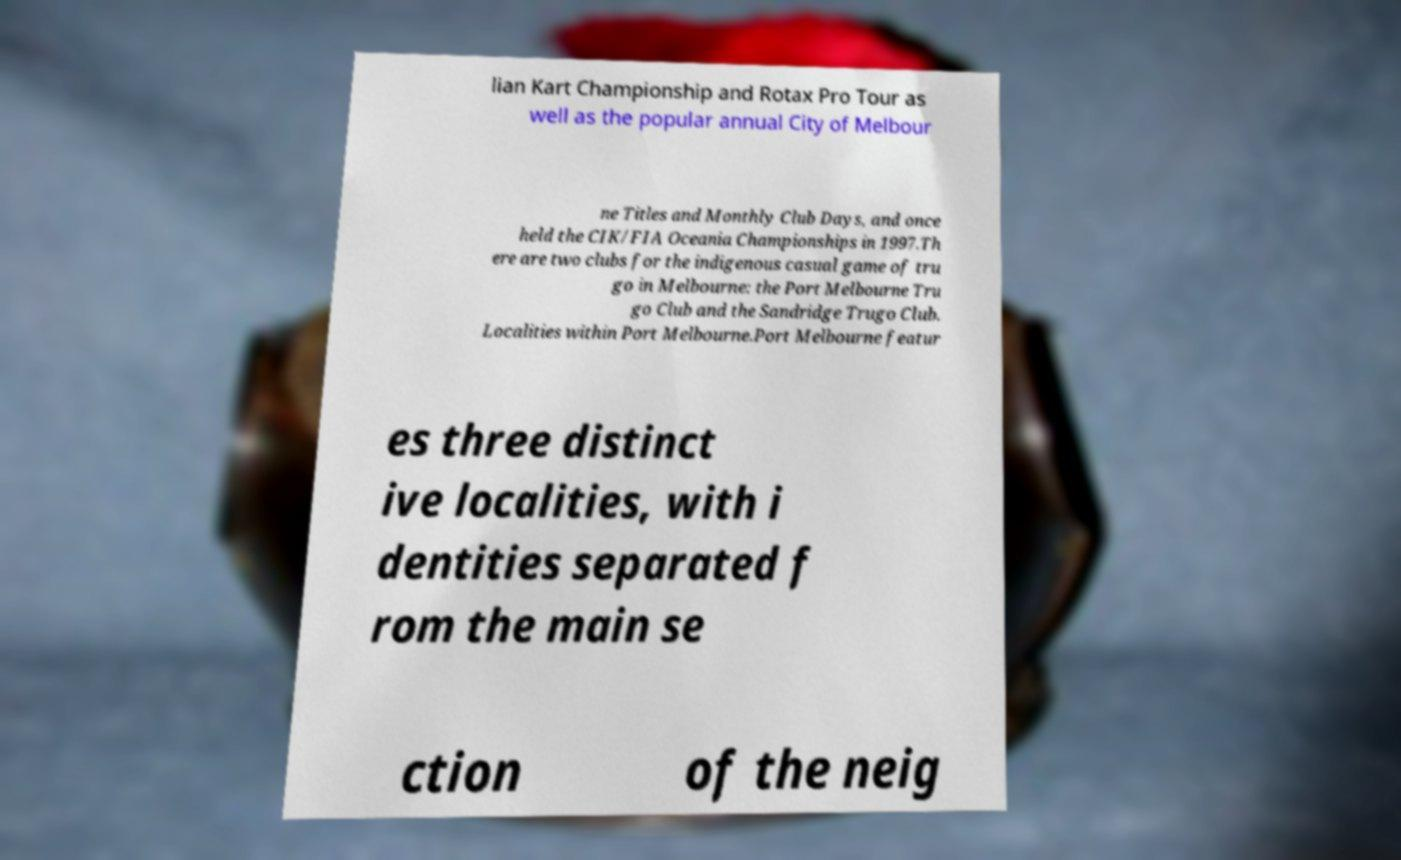Can you read and provide the text displayed in the image?This photo seems to have some interesting text. Can you extract and type it out for me? lian Kart Championship and Rotax Pro Tour as well as the popular annual City of Melbour ne Titles and Monthly Club Days, and once held the CIK/FIA Oceania Championships in 1997.Th ere are two clubs for the indigenous casual game of tru go in Melbourne: the Port Melbourne Tru go Club and the Sandridge Trugo Club. Localities within Port Melbourne.Port Melbourne featur es three distinct ive localities, with i dentities separated f rom the main se ction of the neig 